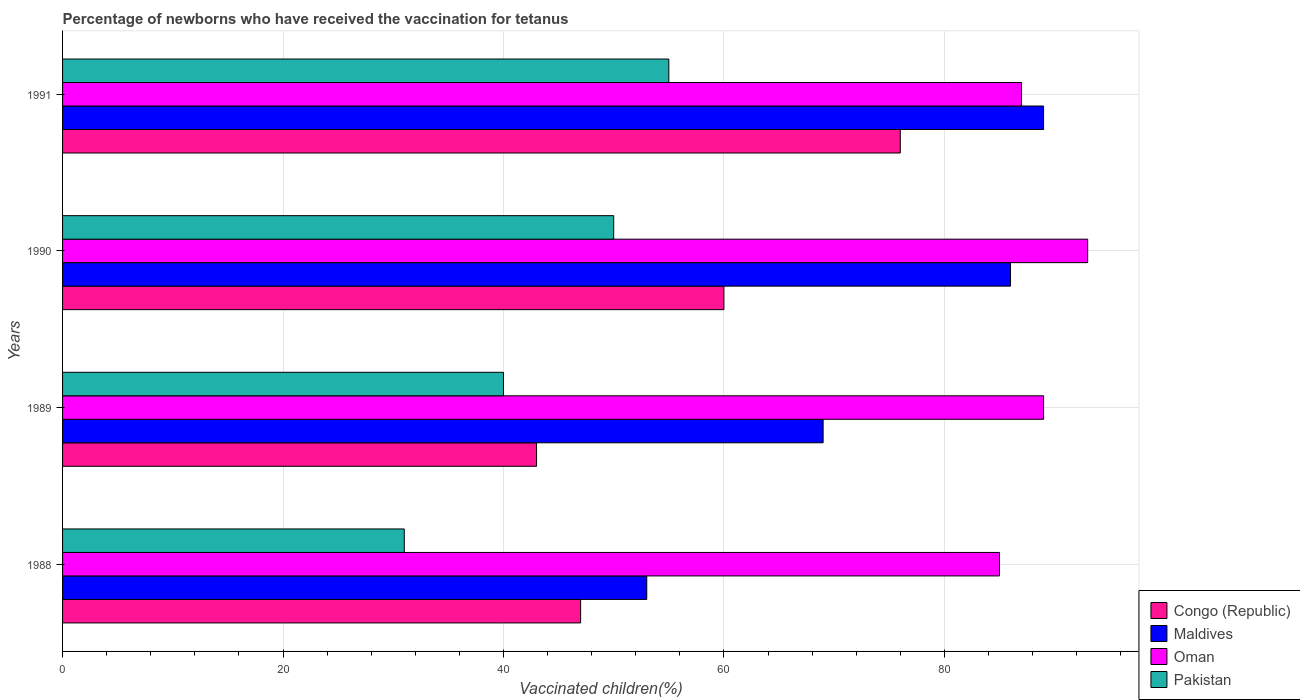How many groups of bars are there?
Provide a short and direct response. 4. Are the number of bars per tick equal to the number of legend labels?
Your response must be concise. Yes. Are the number of bars on each tick of the Y-axis equal?
Ensure brevity in your answer.  Yes. How many bars are there on the 3rd tick from the top?
Give a very brief answer. 4. How many bars are there on the 2nd tick from the bottom?
Provide a succinct answer. 4. What is the percentage of vaccinated children in Oman in 1988?
Keep it short and to the point. 85. Across all years, what is the maximum percentage of vaccinated children in Maldives?
Make the answer very short. 89. Across all years, what is the minimum percentage of vaccinated children in Pakistan?
Offer a very short reply. 31. What is the total percentage of vaccinated children in Maldives in the graph?
Offer a very short reply. 297. What is the difference between the percentage of vaccinated children in Congo (Republic) in 1990 and the percentage of vaccinated children in Pakistan in 1989?
Your answer should be very brief. 20. What is the average percentage of vaccinated children in Oman per year?
Keep it short and to the point. 88.5. In the year 1989, what is the difference between the percentage of vaccinated children in Congo (Republic) and percentage of vaccinated children in Pakistan?
Make the answer very short. 3. In how many years, is the percentage of vaccinated children in Pakistan greater than 32 %?
Ensure brevity in your answer.  3. What is the ratio of the percentage of vaccinated children in Congo (Republic) in 1989 to that in 1991?
Your answer should be very brief. 0.57. Is the percentage of vaccinated children in Congo (Republic) in 1988 less than that in 1990?
Provide a short and direct response. Yes. What is the difference between the highest and the second highest percentage of vaccinated children in Oman?
Offer a terse response. 4. What is the difference between the highest and the lowest percentage of vaccinated children in Congo (Republic)?
Offer a very short reply. 33. What does the 3rd bar from the top in 1988 represents?
Give a very brief answer. Maldives. What does the 3rd bar from the bottom in 1991 represents?
Give a very brief answer. Oman. Is it the case that in every year, the sum of the percentage of vaccinated children in Pakistan and percentage of vaccinated children in Oman is greater than the percentage of vaccinated children in Congo (Republic)?
Offer a very short reply. Yes. How many bars are there?
Your answer should be compact. 16. Are all the bars in the graph horizontal?
Give a very brief answer. Yes. How many years are there in the graph?
Your answer should be very brief. 4. Are the values on the major ticks of X-axis written in scientific E-notation?
Ensure brevity in your answer.  No. Does the graph contain any zero values?
Provide a short and direct response. No. Does the graph contain grids?
Provide a succinct answer. Yes. Where does the legend appear in the graph?
Offer a terse response. Bottom right. How many legend labels are there?
Offer a very short reply. 4. How are the legend labels stacked?
Make the answer very short. Vertical. What is the title of the graph?
Give a very brief answer. Percentage of newborns who have received the vaccination for tetanus. What is the label or title of the X-axis?
Ensure brevity in your answer.  Vaccinated children(%). What is the Vaccinated children(%) in Congo (Republic) in 1988?
Offer a very short reply. 47. What is the Vaccinated children(%) of Maldives in 1988?
Provide a short and direct response. 53. What is the Vaccinated children(%) of Oman in 1988?
Ensure brevity in your answer.  85. What is the Vaccinated children(%) of Congo (Republic) in 1989?
Make the answer very short. 43. What is the Vaccinated children(%) of Maldives in 1989?
Keep it short and to the point. 69. What is the Vaccinated children(%) in Oman in 1989?
Your answer should be compact. 89. What is the Vaccinated children(%) of Congo (Republic) in 1990?
Ensure brevity in your answer.  60. What is the Vaccinated children(%) in Oman in 1990?
Keep it short and to the point. 93. What is the Vaccinated children(%) of Pakistan in 1990?
Keep it short and to the point. 50. What is the Vaccinated children(%) of Congo (Republic) in 1991?
Provide a short and direct response. 76. What is the Vaccinated children(%) in Maldives in 1991?
Your answer should be very brief. 89. What is the Vaccinated children(%) of Oman in 1991?
Make the answer very short. 87. What is the Vaccinated children(%) of Pakistan in 1991?
Give a very brief answer. 55. Across all years, what is the maximum Vaccinated children(%) in Maldives?
Make the answer very short. 89. Across all years, what is the maximum Vaccinated children(%) of Oman?
Ensure brevity in your answer.  93. Across all years, what is the minimum Vaccinated children(%) of Maldives?
Offer a very short reply. 53. Across all years, what is the minimum Vaccinated children(%) in Oman?
Keep it short and to the point. 85. What is the total Vaccinated children(%) of Congo (Republic) in the graph?
Your response must be concise. 226. What is the total Vaccinated children(%) of Maldives in the graph?
Your answer should be compact. 297. What is the total Vaccinated children(%) in Oman in the graph?
Keep it short and to the point. 354. What is the total Vaccinated children(%) of Pakistan in the graph?
Keep it short and to the point. 176. What is the difference between the Vaccinated children(%) in Maldives in 1988 and that in 1989?
Keep it short and to the point. -16. What is the difference between the Vaccinated children(%) in Oman in 1988 and that in 1989?
Your answer should be compact. -4. What is the difference between the Vaccinated children(%) of Pakistan in 1988 and that in 1989?
Your response must be concise. -9. What is the difference between the Vaccinated children(%) of Maldives in 1988 and that in 1990?
Keep it short and to the point. -33. What is the difference between the Vaccinated children(%) of Oman in 1988 and that in 1990?
Your response must be concise. -8. What is the difference between the Vaccinated children(%) in Pakistan in 1988 and that in 1990?
Your answer should be very brief. -19. What is the difference between the Vaccinated children(%) of Maldives in 1988 and that in 1991?
Keep it short and to the point. -36. What is the difference between the Vaccinated children(%) in Maldives in 1989 and that in 1990?
Offer a very short reply. -17. What is the difference between the Vaccinated children(%) in Oman in 1989 and that in 1990?
Your response must be concise. -4. What is the difference between the Vaccinated children(%) of Congo (Republic) in 1989 and that in 1991?
Provide a short and direct response. -33. What is the difference between the Vaccinated children(%) of Maldives in 1989 and that in 1991?
Ensure brevity in your answer.  -20. What is the difference between the Vaccinated children(%) in Oman in 1989 and that in 1991?
Make the answer very short. 2. What is the difference between the Vaccinated children(%) of Pakistan in 1989 and that in 1991?
Offer a terse response. -15. What is the difference between the Vaccinated children(%) of Congo (Republic) in 1988 and the Vaccinated children(%) of Maldives in 1989?
Give a very brief answer. -22. What is the difference between the Vaccinated children(%) in Congo (Republic) in 1988 and the Vaccinated children(%) in Oman in 1989?
Provide a succinct answer. -42. What is the difference between the Vaccinated children(%) in Congo (Republic) in 1988 and the Vaccinated children(%) in Pakistan in 1989?
Your response must be concise. 7. What is the difference between the Vaccinated children(%) in Maldives in 1988 and the Vaccinated children(%) in Oman in 1989?
Offer a terse response. -36. What is the difference between the Vaccinated children(%) in Maldives in 1988 and the Vaccinated children(%) in Pakistan in 1989?
Ensure brevity in your answer.  13. What is the difference between the Vaccinated children(%) of Oman in 1988 and the Vaccinated children(%) of Pakistan in 1989?
Your response must be concise. 45. What is the difference between the Vaccinated children(%) of Congo (Republic) in 1988 and the Vaccinated children(%) of Maldives in 1990?
Keep it short and to the point. -39. What is the difference between the Vaccinated children(%) of Congo (Republic) in 1988 and the Vaccinated children(%) of Oman in 1990?
Provide a succinct answer. -46. What is the difference between the Vaccinated children(%) of Maldives in 1988 and the Vaccinated children(%) of Oman in 1990?
Provide a succinct answer. -40. What is the difference between the Vaccinated children(%) in Maldives in 1988 and the Vaccinated children(%) in Pakistan in 1990?
Ensure brevity in your answer.  3. What is the difference between the Vaccinated children(%) of Oman in 1988 and the Vaccinated children(%) of Pakistan in 1990?
Ensure brevity in your answer.  35. What is the difference between the Vaccinated children(%) in Congo (Republic) in 1988 and the Vaccinated children(%) in Maldives in 1991?
Ensure brevity in your answer.  -42. What is the difference between the Vaccinated children(%) in Congo (Republic) in 1988 and the Vaccinated children(%) in Pakistan in 1991?
Ensure brevity in your answer.  -8. What is the difference between the Vaccinated children(%) in Maldives in 1988 and the Vaccinated children(%) in Oman in 1991?
Give a very brief answer. -34. What is the difference between the Vaccinated children(%) of Congo (Republic) in 1989 and the Vaccinated children(%) of Maldives in 1990?
Make the answer very short. -43. What is the difference between the Vaccinated children(%) of Congo (Republic) in 1989 and the Vaccinated children(%) of Oman in 1990?
Your answer should be very brief. -50. What is the difference between the Vaccinated children(%) in Oman in 1989 and the Vaccinated children(%) in Pakistan in 1990?
Your answer should be compact. 39. What is the difference between the Vaccinated children(%) in Congo (Republic) in 1989 and the Vaccinated children(%) in Maldives in 1991?
Make the answer very short. -46. What is the difference between the Vaccinated children(%) of Congo (Republic) in 1989 and the Vaccinated children(%) of Oman in 1991?
Provide a succinct answer. -44. What is the difference between the Vaccinated children(%) of Maldives in 1989 and the Vaccinated children(%) of Oman in 1991?
Keep it short and to the point. -18. What is the difference between the Vaccinated children(%) in Oman in 1989 and the Vaccinated children(%) in Pakistan in 1991?
Make the answer very short. 34. What is the difference between the Vaccinated children(%) in Congo (Republic) in 1990 and the Vaccinated children(%) in Oman in 1991?
Make the answer very short. -27. What is the difference between the Vaccinated children(%) of Maldives in 1990 and the Vaccinated children(%) of Oman in 1991?
Offer a very short reply. -1. What is the difference between the Vaccinated children(%) in Maldives in 1990 and the Vaccinated children(%) in Pakistan in 1991?
Your answer should be compact. 31. What is the difference between the Vaccinated children(%) in Oman in 1990 and the Vaccinated children(%) in Pakistan in 1991?
Make the answer very short. 38. What is the average Vaccinated children(%) of Congo (Republic) per year?
Your answer should be compact. 56.5. What is the average Vaccinated children(%) in Maldives per year?
Your answer should be very brief. 74.25. What is the average Vaccinated children(%) of Oman per year?
Make the answer very short. 88.5. In the year 1988, what is the difference between the Vaccinated children(%) in Congo (Republic) and Vaccinated children(%) in Oman?
Provide a succinct answer. -38. In the year 1988, what is the difference between the Vaccinated children(%) of Maldives and Vaccinated children(%) of Oman?
Make the answer very short. -32. In the year 1988, what is the difference between the Vaccinated children(%) in Oman and Vaccinated children(%) in Pakistan?
Make the answer very short. 54. In the year 1989, what is the difference between the Vaccinated children(%) of Congo (Republic) and Vaccinated children(%) of Maldives?
Offer a very short reply. -26. In the year 1989, what is the difference between the Vaccinated children(%) of Congo (Republic) and Vaccinated children(%) of Oman?
Keep it short and to the point. -46. In the year 1989, what is the difference between the Vaccinated children(%) of Maldives and Vaccinated children(%) of Oman?
Your response must be concise. -20. In the year 1989, what is the difference between the Vaccinated children(%) in Maldives and Vaccinated children(%) in Pakistan?
Your answer should be very brief. 29. In the year 1989, what is the difference between the Vaccinated children(%) of Oman and Vaccinated children(%) of Pakistan?
Give a very brief answer. 49. In the year 1990, what is the difference between the Vaccinated children(%) in Congo (Republic) and Vaccinated children(%) in Maldives?
Ensure brevity in your answer.  -26. In the year 1990, what is the difference between the Vaccinated children(%) in Congo (Republic) and Vaccinated children(%) in Oman?
Your answer should be compact. -33. In the year 1990, what is the difference between the Vaccinated children(%) in Congo (Republic) and Vaccinated children(%) in Pakistan?
Give a very brief answer. 10. In the year 1990, what is the difference between the Vaccinated children(%) in Maldives and Vaccinated children(%) in Oman?
Make the answer very short. -7. In the year 1990, what is the difference between the Vaccinated children(%) in Maldives and Vaccinated children(%) in Pakistan?
Offer a very short reply. 36. In the year 1991, what is the difference between the Vaccinated children(%) of Maldives and Vaccinated children(%) of Oman?
Provide a short and direct response. 2. In the year 1991, what is the difference between the Vaccinated children(%) in Maldives and Vaccinated children(%) in Pakistan?
Make the answer very short. 34. In the year 1991, what is the difference between the Vaccinated children(%) of Oman and Vaccinated children(%) of Pakistan?
Give a very brief answer. 32. What is the ratio of the Vaccinated children(%) in Congo (Republic) in 1988 to that in 1989?
Provide a short and direct response. 1.09. What is the ratio of the Vaccinated children(%) in Maldives in 1988 to that in 1989?
Give a very brief answer. 0.77. What is the ratio of the Vaccinated children(%) in Oman in 1988 to that in 1989?
Keep it short and to the point. 0.96. What is the ratio of the Vaccinated children(%) in Pakistan in 1988 to that in 1989?
Provide a short and direct response. 0.78. What is the ratio of the Vaccinated children(%) of Congo (Republic) in 1988 to that in 1990?
Provide a succinct answer. 0.78. What is the ratio of the Vaccinated children(%) in Maldives in 1988 to that in 1990?
Your answer should be compact. 0.62. What is the ratio of the Vaccinated children(%) of Oman in 1988 to that in 1990?
Provide a short and direct response. 0.91. What is the ratio of the Vaccinated children(%) in Pakistan in 1988 to that in 1990?
Provide a succinct answer. 0.62. What is the ratio of the Vaccinated children(%) of Congo (Republic) in 1988 to that in 1991?
Keep it short and to the point. 0.62. What is the ratio of the Vaccinated children(%) in Maldives in 1988 to that in 1991?
Offer a very short reply. 0.6. What is the ratio of the Vaccinated children(%) of Oman in 1988 to that in 1991?
Provide a succinct answer. 0.98. What is the ratio of the Vaccinated children(%) in Pakistan in 1988 to that in 1991?
Provide a short and direct response. 0.56. What is the ratio of the Vaccinated children(%) of Congo (Republic) in 1989 to that in 1990?
Your answer should be very brief. 0.72. What is the ratio of the Vaccinated children(%) of Maldives in 1989 to that in 1990?
Your answer should be compact. 0.8. What is the ratio of the Vaccinated children(%) in Oman in 1989 to that in 1990?
Keep it short and to the point. 0.96. What is the ratio of the Vaccinated children(%) in Congo (Republic) in 1989 to that in 1991?
Keep it short and to the point. 0.57. What is the ratio of the Vaccinated children(%) in Maldives in 1989 to that in 1991?
Provide a short and direct response. 0.78. What is the ratio of the Vaccinated children(%) of Pakistan in 1989 to that in 1991?
Provide a succinct answer. 0.73. What is the ratio of the Vaccinated children(%) of Congo (Republic) in 1990 to that in 1991?
Offer a very short reply. 0.79. What is the ratio of the Vaccinated children(%) in Maldives in 1990 to that in 1991?
Offer a terse response. 0.97. What is the ratio of the Vaccinated children(%) of Oman in 1990 to that in 1991?
Offer a very short reply. 1.07. What is the ratio of the Vaccinated children(%) of Pakistan in 1990 to that in 1991?
Ensure brevity in your answer.  0.91. What is the difference between the highest and the second highest Vaccinated children(%) in Oman?
Give a very brief answer. 4. What is the difference between the highest and the lowest Vaccinated children(%) of Pakistan?
Provide a short and direct response. 24. 